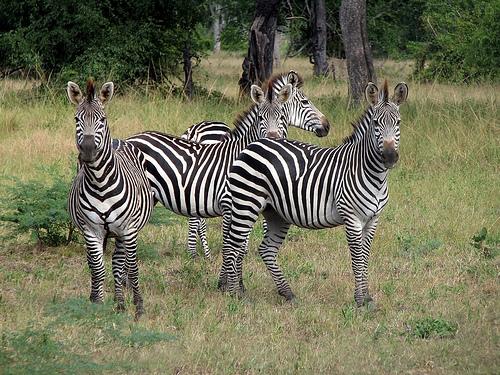Are the zebras wild?
Answer briefly. Yes. How many zebras are facing the right?
Write a very short answer. 1. Are the zebra in an urban zoo?
Concise answer only. No. Are these animals in their natural habitat?
Answer briefly. Yes. 